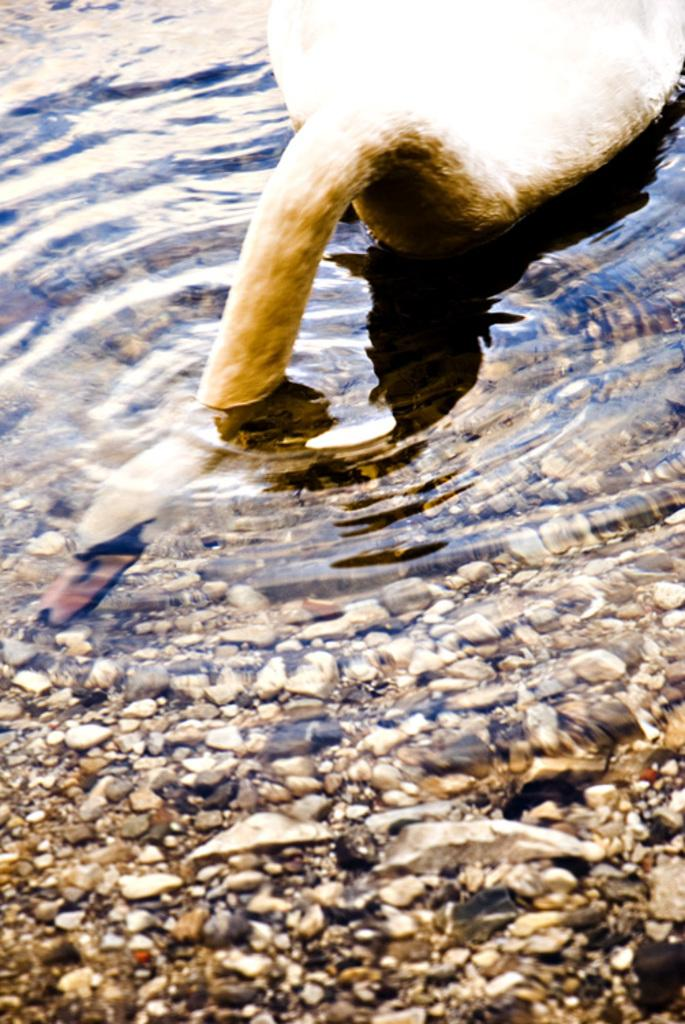What type of animal can be seen in the image? There is a bird in the image. Where is the bird located? The bird is in the water. What else can be seen in the water besides the bird? There are rocks in the water. What type of straw is the bird using to drink water in the image? There is no straw present in the image; the bird is in the water but not using any straw to drink. 